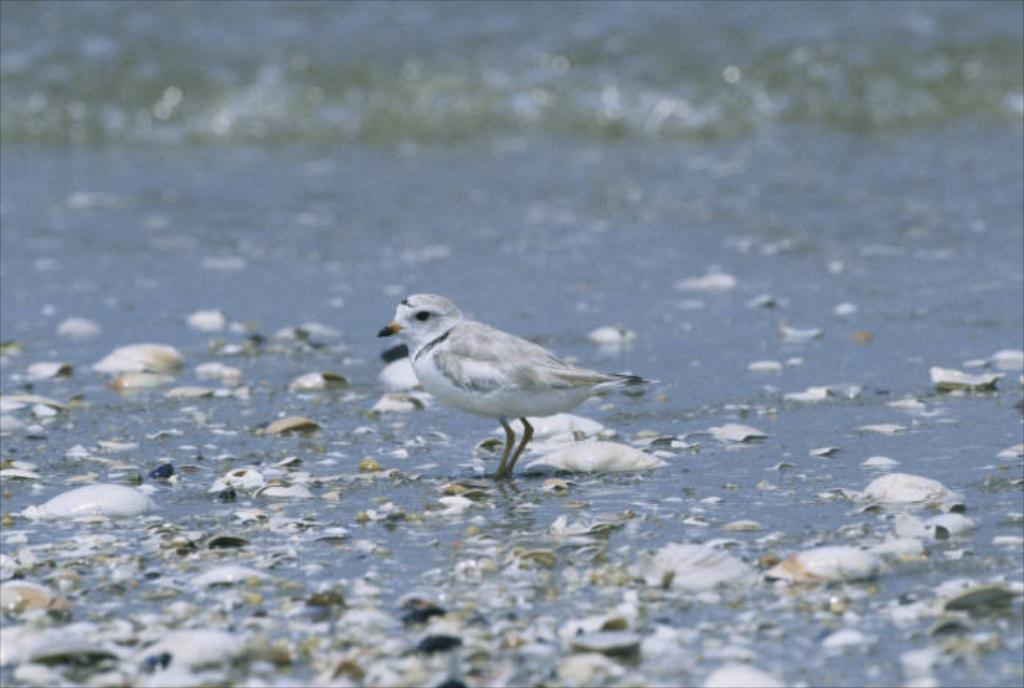What type of animal is present in the image? There is a bird in the image. What is the bird doing in the image? The bird is standing on a surface. Can you describe the condition of the area around the bird? The area around the bird is dirty. What hobbies does the bird have, as seen in the image? The image does not provide information about the bird's hobbies. Is the bird on a roof in the image? The image does not show the bird on a roof; it only shows the bird standing on a surface. 